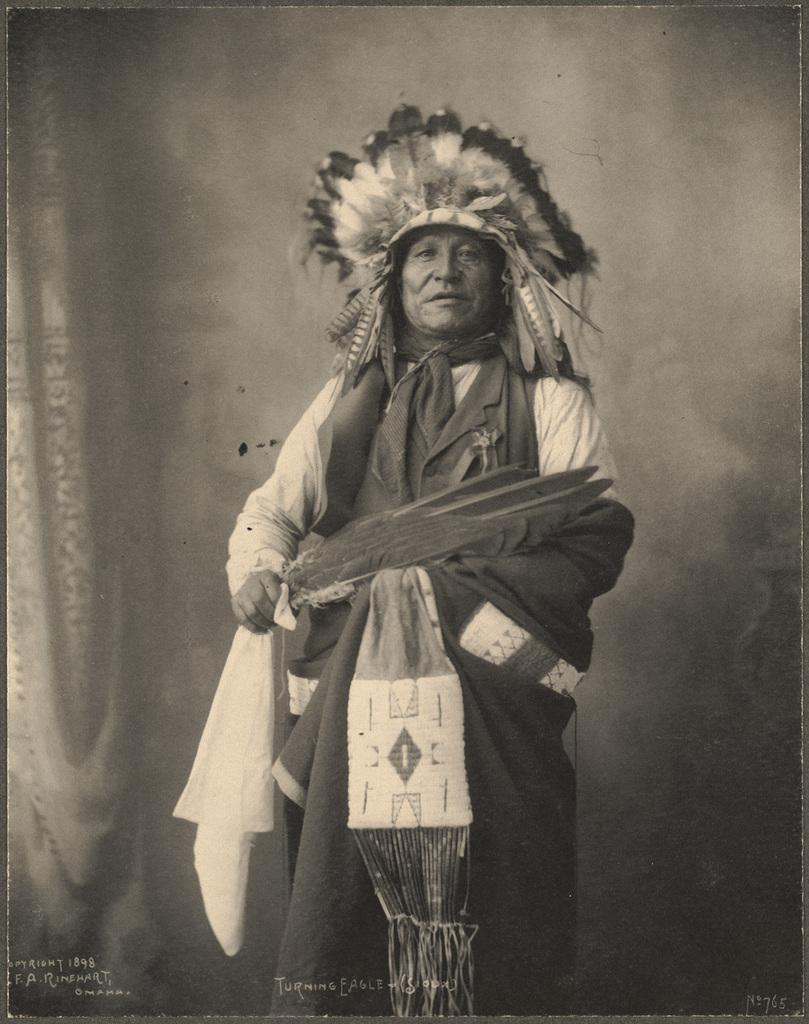What is the main subject of the image? There is a man in the image. What color scheme is used in the image? The image is black and white. What type of soup is the man eating in the image? There is no soup present in the image, as it is a black and white image of a man. What part of the man's brain can be seen in the image? The image is black and white and only shows the man, so no specific part of the brain is visible. 